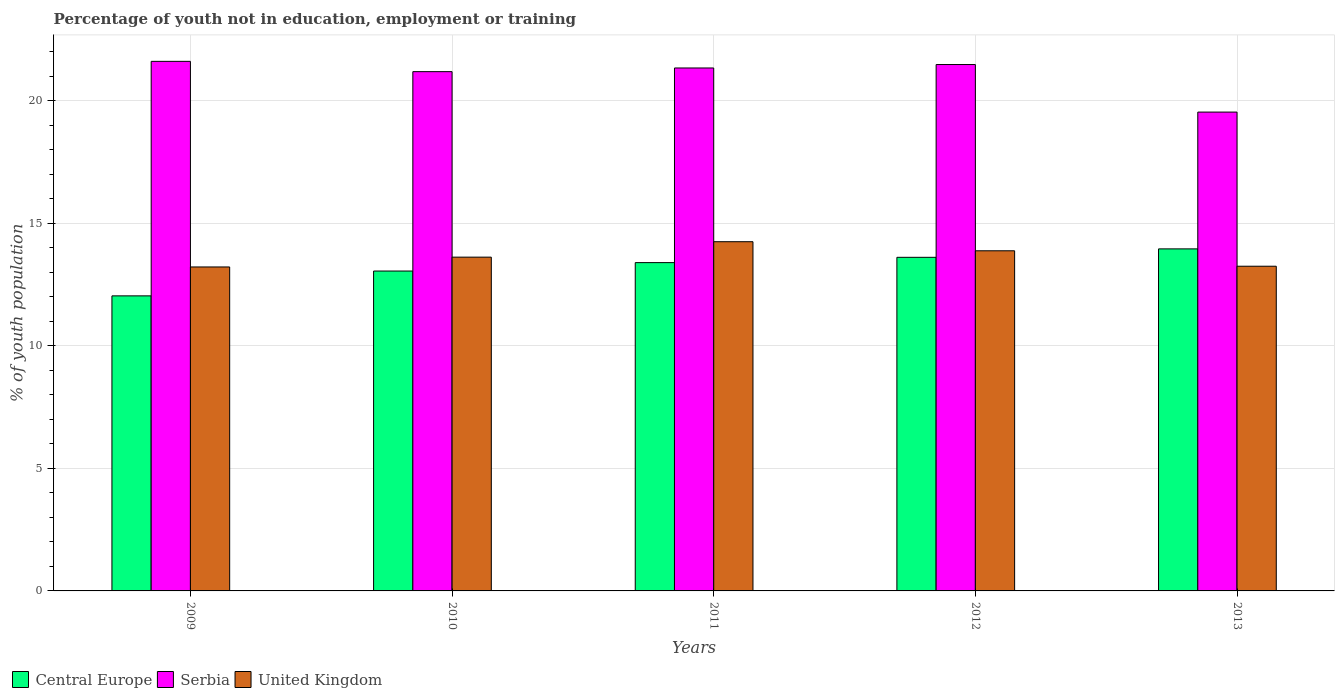How many groups of bars are there?
Your response must be concise. 5. Are the number of bars on each tick of the X-axis equal?
Provide a short and direct response. Yes. How many bars are there on the 4th tick from the right?
Your response must be concise. 3. In how many cases, is the number of bars for a given year not equal to the number of legend labels?
Your answer should be compact. 0. What is the percentage of unemployed youth population in in Serbia in 2009?
Give a very brief answer. 21.61. Across all years, what is the maximum percentage of unemployed youth population in in Central Europe?
Provide a succinct answer. 13.96. Across all years, what is the minimum percentage of unemployed youth population in in United Kingdom?
Ensure brevity in your answer.  13.22. What is the total percentage of unemployed youth population in in United Kingdom in the graph?
Ensure brevity in your answer.  68.22. What is the difference between the percentage of unemployed youth population in in United Kingdom in 2009 and that in 2010?
Offer a very short reply. -0.4. What is the difference between the percentage of unemployed youth population in in Central Europe in 2010 and the percentage of unemployed youth population in in Serbia in 2012?
Offer a terse response. -8.43. What is the average percentage of unemployed youth population in in Serbia per year?
Your answer should be compact. 21.03. In the year 2013, what is the difference between the percentage of unemployed youth population in in Central Europe and percentage of unemployed youth population in in Serbia?
Provide a short and direct response. -5.58. What is the ratio of the percentage of unemployed youth population in in United Kingdom in 2009 to that in 2011?
Provide a short and direct response. 0.93. Is the percentage of unemployed youth population in in Serbia in 2010 less than that in 2012?
Offer a very short reply. Yes. What is the difference between the highest and the second highest percentage of unemployed youth population in in United Kingdom?
Provide a short and direct response. 0.37. What is the difference between the highest and the lowest percentage of unemployed youth population in in Central Europe?
Ensure brevity in your answer.  1.92. What does the 1st bar from the left in 2012 represents?
Provide a succinct answer. Central Europe. What does the 2nd bar from the right in 2011 represents?
Provide a succinct answer. Serbia. Is it the case that in every year, the sum of the percentage of unemployed youth population in in United Kingdom and percentage of unemployed youth population in in Serbia is greater than the percentage of unemployed youth population in in Central Europe?
Your response must be concise. Yes. How many bars are there?
Give a very brief answer. 15. Are all the bars in the graph horizontal?
Ensure brevity in your answer.  No. How many years are there in the graph?
Offer a terse response. 5. What is the difference between two consecutive major ticks on the Y-axis?
Provide a short and direct response. 5. Does the graph contain grids?
Make the answer very short. Yes. Where does the legend appear in the graph?
Ensure brevity in your answer.  Bottom left. How many legend labels are there?
Provide a succinct answer. 3. What is the title of the graph?
Offer a terse response. Percentage of youth not in education, employment or training. What is the label or title of the Y-axis?
Offer a terse response. % of youth population. What is the % of youth population in Central Europe in 2009?
Offer a terse response. 12.04. What is the % of youth population of Serbia in 2009?
Make the answer very short. 21.61. What is the % of youth population of United Kingdom in 2009?
Provide a short and direct response. 13.22. What is the % of youth population of Central Europe in 2010?
Your response must be concise. 13.05. What is the % of youth population in Serbia in 2010?
Give a very brief answer. 21.19. What is the % of youth population of United Kingdom in 2010?
Provide a succinct answer. 13.62. What is the % of youth population of Central Europe in 2011?
Provide a short and direct response. 13.4. What is the % of youth population of Serbia in 2011?
Make the answer very short. 21.34. What is the % of youth population of United Kingdom in 2011?
Keep it short and to the point. 14.25. What is the % of youth population of Central Europe in 2012?
Ensure brevity in your answer.  13.61. What is the % of youth population in Serbia in 2012?
Your answer should be very brief. 21.48. What is the % of youth population of United Kingdom in 2012?
Make the answer very short. 13.88. What is the % of youth population in Central Europe in 2013?
Your answer should be compact. 13.96. What is the % of youth population of Serbia in 2013?
Keep it short and to the point. 19.54. What is the % of youth population in United Kingdom in 2013?
Provide a succinct answer. 13.25. Across all years, what is the maximum % of youth population of Central Europe?
Provide a succinct answer. 13.96. Across all years, what is the maximum % of youth population in Serbia?
Provide a succinct answer. 21.61. Across all years, what is the maximum % of youth population in United Kingdom?
Make the answer very short. 14.25. Across all years, what is the minimum % of youth population in Central Europe?
Make the answer very short. 12.04. Across all years, what is the minimum % of youth population of Serbia?
Keep it short and to the point. 19.54. Across all years, what is the minimum % of youth population of United Kingdom?
Offer a very short reply. 13.22. What is the total % of youth population in Central Europe in the graph?
Make the answer very short. 66.06. What is the total % of youth population of Serbia in the graph?
Your answer should be very brief. 105.16. What is the total % of youth population of United Kingdom in the graph?
Offer a very short reply. 68.22. What is the difference between the % of youth population of Central Europe in 2009 and that in 2010?
Give a very brief answer. -1.01. What is the difference between the % of youth population in Serbia in 2009 and that in 2010?
Give a very brief answer. 0.42. What is the difference between the % of youth population of Central Europe in 2009 and that in 2011?
Make the answer very short. -1.36. What is the difference between the % of youth population in Serbia in 2009 and that in 2011?
Your answer should be very brief. 0.27. What is the difference between the % of youth population in United Kingdom in 2009 and that in 2011?
Your answer should be compact. -1.03. What is the difference between the % of youth population in Central Europe in 2009 and that in 2012?
Give a very brief answer. -1.57. What is the difference between the % of youth population in Serbia in 2009 and that in 2012?
Keep it short and to the point. 0.13. What is the difference between the % of youth population in United Kingdom in 2009 and that in 2012?
Ensure brevity in your answer.  -0.66. What is the difference between the % of youth population in Central Europe in 2009 and that in 2013?
Give a very brief answer. -1.92. What is the difference between the % of youth population in Serbia in 2009 and that in 2013?
Ensure brevity in your answer.  2.07. What is the difference between the % of youth population in United Kingdom in 2009 and that in 2013?
Your answer should be compact. -0.03. What is the difference between the % of youth population in Central Europe in 2010 and that in 2011?
Your answer should be very brief. -0.34. What is the difference between the % of youth population in United Kingdom in 2010 and that in 2011?
Provide a succinct answer. -0.63. What is the difference between the % of youth population of Central Europe in 2010 and that in 2012?
Your answer should be very brief. -0.56. What is the difference between the % of youth population of Serbia in 2010 and that in 2012?
Make the answer very short. -0.29. What is the difference between the % of youth population in United Kingdom in 2010 and that in 2012?
Make the answer very short. -0.26. What is the difference between the % of youth population of Central Europe in 2010 and that in 2013?
Provide a succinct answer. -0.9. What is the difference between the % of youth population of Serbia in 2010 and that in 2013?
Your answer should be very brief. 1.65. What is the difference between the % of youth population in United Kingdom in 2010 and that in 2013?
Give a very brief answer. 0.37. What is the difference between the % of youth population of Central Europe in 2011 and that in 2012?
Offer a terse response. -0.22. What is the difference between the % of youth population in Serbia in 2011 and that in 2012?
Offer a terse response. -0.14. What is the difference between the % of youth population of United Kingdom in 2011 and that in 2012?
Provide a short and direct response. 0.37. What is the difference between the % of youth population of Central Europe in 2011 and that in 2013?
Provide a succinct answer. -0.56. What is the difference between the % of youth population in Serbia in 2011 and that in 2013?
Offer a very short reply. 1.8. What is the difference between the % of youth population in Central Europe in 2012 and that in 2013?
Your answer should be compact. -0.34. What is the difference between the % of youth population of Serbia in 2012 and that in 2013?
Provide a succinct answer. 1.94. What is the difference between the % of youth population of United Kingdom in 2012 and that in 2013?
Keep it short and to the point. 0.63. What is the difference between the % of youth population in Central Europe in 2009 and the % of youth population in Serbia in 2010?
Provide a short and direct response. -9.15. What is the difference between the % of youth population of Central Europe in 2009 and the % of youth population of United Kingdom in 2010?
Offer a very short reply. -1.58. What is the difference between the % of youth population in Serbia in 2009 and the % of youth population in United Kingdom in 2010?
Your answer should be very brief. 7.99. What is the difference between the % of youth population of Central Europe in 2009 and the % of youth population of Serbia in 2011?
Your answer should be compact. -9.3. What is the difference between the % of youth population in Central Europe in 2009 and the % of youth population in United Kingdom in 2011?
Keep it short and to the point. -2.21. What is the difference between the % of youth population of Serbia in 2009 and the % of youth population of United Kingdom in 2011?
Your answer should be compact. 7.36. What is the difference between the % of youth population of Central Europe in 2009 and the % of youth population of Serbia in 2012?
Your response must be concise. -9.44. What is the difference between the % of youth population of Central Europe in 2009 and the % of youth population of United Kingdom in 2012?
Your answer should be very brief. -1.84. What is the difference between the % of youth population of Serbia in 2009 and the % of youth population of United Kingdom in 2012?
Provide a short and direct response. 7.73. What is the difference between the % of youth population of Central Europe in 2009 and the % of youth population of Serbia in 2013?
Provide a short and direct response. -7.5. What is the difference between the % of youth population in Central Europe in 2009 and the % of youth population in United Kingdom in 2013?
Ensure brevity in your answer.  -1.21. What is the difference between the % of youth population in Serbia in 2009 and the % of youth population in United Kingdom in 2013?
Keep it short and to the point. 8.36. What is the difference between the % of youth population in Central Europe in 2010 and the % of youth population in Serbia in 2011?
Keep it short and to the point. -8.29. What is the difference between the % of youth population of Central Europe in 2010 and the % of youth population of United Kingdom in 2011?
Offer a terse response. -1.2. What is the difference between the % of youth population of Serbia in 2010 and the % of youth population of United Kingdom in 2011?
Make the answer very short. 6.94. What is the difference between the % of youth population of Central Europe in 2010 and the % of youth population of Serbia in 2012?
Provide a succinct answer. -8.43. What is the difference between the % of youth population of Central Europe in 2010 and the % of youth population of United Kingdom in 2012?
Offer a very short reply. -0.83. What is the difference between the % of youth population in Serbia in 2010 and the % of youth population in United Kingdom in 2012?
Your answer should be very brief. 7.31. What is the difference between the % of youth population in Central Europe in 2010 and the % of youth population in Serbia in 2013?
Ensure brevity in your answer.  -6.49. What is the difference between the % of youth population of Central Europe in 2010 and the % of youth population of United Kingdom in 2013?
Make the answer very short. -0.2. What is the difference between the % of youth population in Serbia in 2010 and the % of youth population in United Kingdom in 2013?
Make the answer very short. 7.94. What is the difference between the % of youth population of Central Europe in 2011 and the % of youth population of Serbia in 2012?
Your response must be concise. -8.08. What is the difference between the % of youth population of Central Europe in 2011 and the % of youth population of United Kingdom in 2012?
Provide a short and direct response. -0.48. What is the difference between the % of youth population in Serbia in 2011 and the % of youth population in United Kingdom in 2012?
Your answer should be very brief. 7.46. What is the difference between the % of youth population of Central Europe in 2011 and the % of youth population of Serbia in 2013?
Your response must be concise. -6.14. What is the difference between the % of youth population in Central Europe in 2011 and the % of youth population in United Kingdom in 2013?
Your answer should be very brief. 0.15. What is the difference between the % of youth population of Serbia in 2011 and the % of youth population of United Kingdom in 2013?
Give a very brief answer. 8.09. What is the difference between the % of youth population in Central Europe in 2012 and the % of youth population in Serbia in 2013?
Your answer should be compact. -5.93. What is the difference between the % of youth population of Central Europe in 2012 and the % of youth population of United Kingdom in 2013?
Your response must be concise. 0.36. What is the difference between the % of youth population of Serbia in 2012 and the % of youth population of United Kingdom in 2013?
Make the answer very short. 8.23. What is the average % of youth population of Central Europe per year?
Offer a terse response. 13.21. What is the average % of youth population of Serbia per year?
Give a very brief answer. 21.03. What is the average % of youth population of United Kingdom per year?
Offer a terse response. 13.64. In the year 2009, what is the difference between the % of youth population of Central Europe and % of youth population of Serbia?
Offer a very short reply. -9.57. In the year 2009, what is the difference between the % of youth population in Central Europe and % of youth population in United Kingdom?
Make the answer very short. -1.18. In the year 2009, what is the difference between the % of youth population in Serbia and % of youth population in United Kingdom?
Your response must be concise. 8.39. In the year 2010, what is the difference between the % of youth population in Central Europe and % of youth population in Serbia?
Offer a very short reply. -8.14. In the year 2010, what is the difference between the % of youth population of Central Europe and % of youth population of United Kingdom?
Ensure brevity in your answer.  -0.57. In the year 2010, what is the difference between the % of youth population of Serbia and % of youth population of United Kingdom?
Give a very brief answer. 7.57. In the year 2011, what is the difference between the % of youth population of Central Europe and % of youth population of Serbia?
Provide a short and direct response. -7.94. In the year 2011, what is the difference between the % of youth population in Central Europe and % of youth population in United Kingdom?
Ensure brevity in your answer.  -0.85. In the year 2011, what is the difference between the % of youth population of Serbia and % of youth population of United Kingdom?
Your answer should be compact. 7.09. In the year 2012, what is the difference between the % of youth population of Central Europe and % of youth population of Serbia?
Make the answer very short. -7.87. In the year 2012, what is the difference between the % of youth population in Central Europe and % of youth population in United Kingdom?
Your response must be concise. -0.27. In the year 2012, what is the difference between the % of youth population in Serbia and % of youth population in United Kingdom?
Your response must be concise. 7.6. In the year 2013, what is the difference between the % of youth population of Central Europe and % of youth population of Serbia?
Provide a succinct answer. -5.58. In the year 2013, what is the difference between the % of youth population in Central Europe and % of youth population in United Kingdom?
Provide a succinct answer. 0.71. In the year 2013, what is the difference between the % of youth population in Serbia and % of youth population in United Kingdom?
Offer a terse response. 6.29. What is the ratio of the % of youth population of Central Europe in 2009 to that in 2010?
Keep it short and to the point. 0.92. What is the ratio of the % of youth population in Serbia in 2009 to that in 2010?
Your answer should be very brief. 1.02. What is the ratio of the % of youth population in United Kingdom in 2009 to that in 2010?
Your answer should be compact. 0.97. What is the ratio of the % of youth population of Central Europe in 2009 to that in 2011?
Give a very brief answer. 0.9. What is the ratio of the % of youth population in Serbia in 2009 to that in 2011?
Offer a very short reply. 1.01. What is the ratio of the % of youth population of United Kingdom in 2009 to that in 2011?
Your response must be concise. 0.93. What is the ratio of the % of youth population in Central Europe in 2009 to that in 2012?
Your answer should be very brief. 0.88. What is the ratio of the % of youth population of Serbia in 2009 to that in 2012?
Make the answer very short. 1.01. What is the ratio of the % of youth population of Central Europe in 2009 to that in 2013?
Your answer should be very brief. 0.86. What is the ratio of the % of youth population of Serbia in 2009 to that in 2013?
Provide a short and direct response. 1.11. What is the ratio of the % of youth population of United Kingdom in 2009 to that in 2013?
Offer a very short reply. 1. What is the ratio of the % of youth population of Central Europe in 2010 to that in 2011?
Offer a very short reply. 0.97. What is the ratio of the % of youth population in Serbia in 2010 to that in 2011?
Offer a very short reply. 0.99. What is the ratio of the % of youth population of United Kingdom in 2010 to that in 2011?
Offer a very short reply. 0.96. What is the ratio of the % of youth population in Central Europe in 2010 to that in 2012?
Make the answer very short. 0.96. What is the ratio of the % of youth population in Serbia in 2010 to that in 2012?
Offer a very short reply. 0.99. What is the ratio of the % of youth population in United Kingdom in 2010 to that in 2012?
Give a very brief answer. 0.98. What is the ratio of the % of youth population of Central Europe in 2010 to that in 2013?
Offer a very short reply. 0.94. What is the ratio of the % of youth population in Serbia in 2010 to that in 2013?
Offer a very short reply. 1.08. What is the ratio of the % of youth population of United Kingdom in 2010 to that in 2013?
Ensure brevity in your answer.  1.03. What is the ratio of the % of youth population of Central Europe in 2011 to that in 2012?
Offer a terse response. 0.98. What is the ratio of the % of youth population of Serbia in 2011 to that in 2012?
Offer a terse response. 0.99. What is the ratio of the % of youth population in United Kingdom in 2011 to that in 2012?
Give a very brief answer. 1.03. What is the ratio of the % of youth population of Central Europe in 2011 to that in 2013?
Ensure brevity in your answer.  0.96. What is the ratio of the % of youth population in Serbia in 2011 to that in 2013?
Give a very brief answer. 1.09. What is the ratio of the % of youth population in United Kingdom in 2011 to that in 2013?
Your answer should be very brief. 1.08. What is the ratio of the % of youth population in Central Europe in 2012 to that in 2013?
Provide a succinct answer. 0.98. What is the ratio of the % of youth population of Serbia in 2012 to that in 2013?
Keep it short and to the point. 1.1. What is the ratio of the % of youth population in United Kingdom in 2012 to that in 2013?
Your response must be concise. 1.05. What is the difference between the highest and the second highest % of youth population in Central Europe?
Keep it short and to the point. 0.34. What is the difference between the highest and the second highest % of youth population of Serbia?
Offer a very short reply. 0.13. What is the difference between the highest and the second highest % of youth population of United Kingdom?
Provide a succinct answer. 0.37. What is the difference between the highest and the lowest % of youth population in Central Europe?
Provide a short and direct response. 1.92. What is the difference between the highest and the lowest % of youth population in Serbia?
Your response must be concise. 2.07. What is the difference between the highest and the lowest % of youth population in United Kingdom?
Your answer should be very brief. 1.03. 